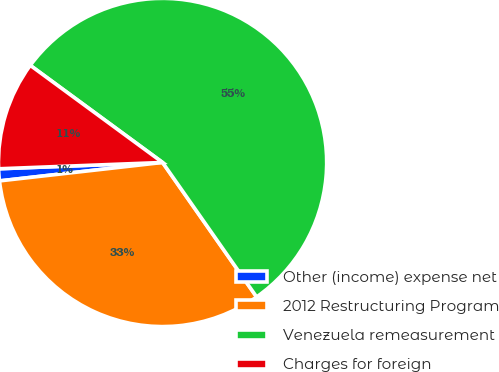<chart> <loc_0><loc_0><loc_500><loc_500><pie_chart><fcel>Other (income) expense net<fcel>2012 Restructuring Program<fcel>Venezuela remeasurement<fcel>Charges for foreign<nl><fcel>1.18%<fcel>32.92%<fcel>55.21%<fcel>10.69%<nl></chart> 